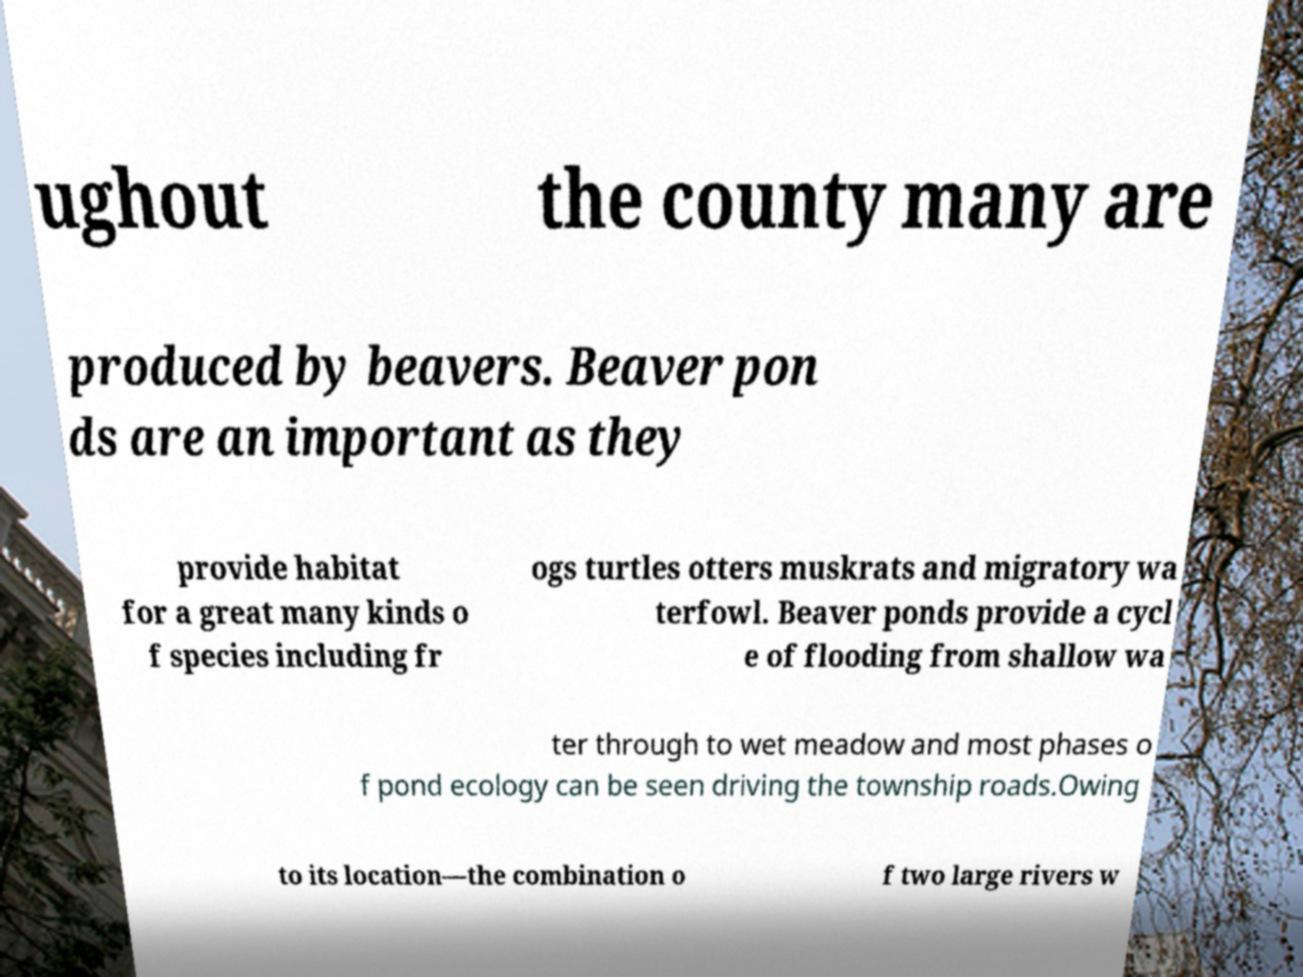Could you extract and type out the text from this image? ughout the county many are produced by beavers. Beaver pon ds are an important as they provide habitat for a great many kinds o f species including fr ogs turtles otters muskrats and migratory wa terfowl. Beaver ponds provide a cycl e of flooding from shallow wa ter through to wet meadow and most phases o f pond ecology can be seen driving the township roads.Owing to its location—the combination o f two large rivers w 